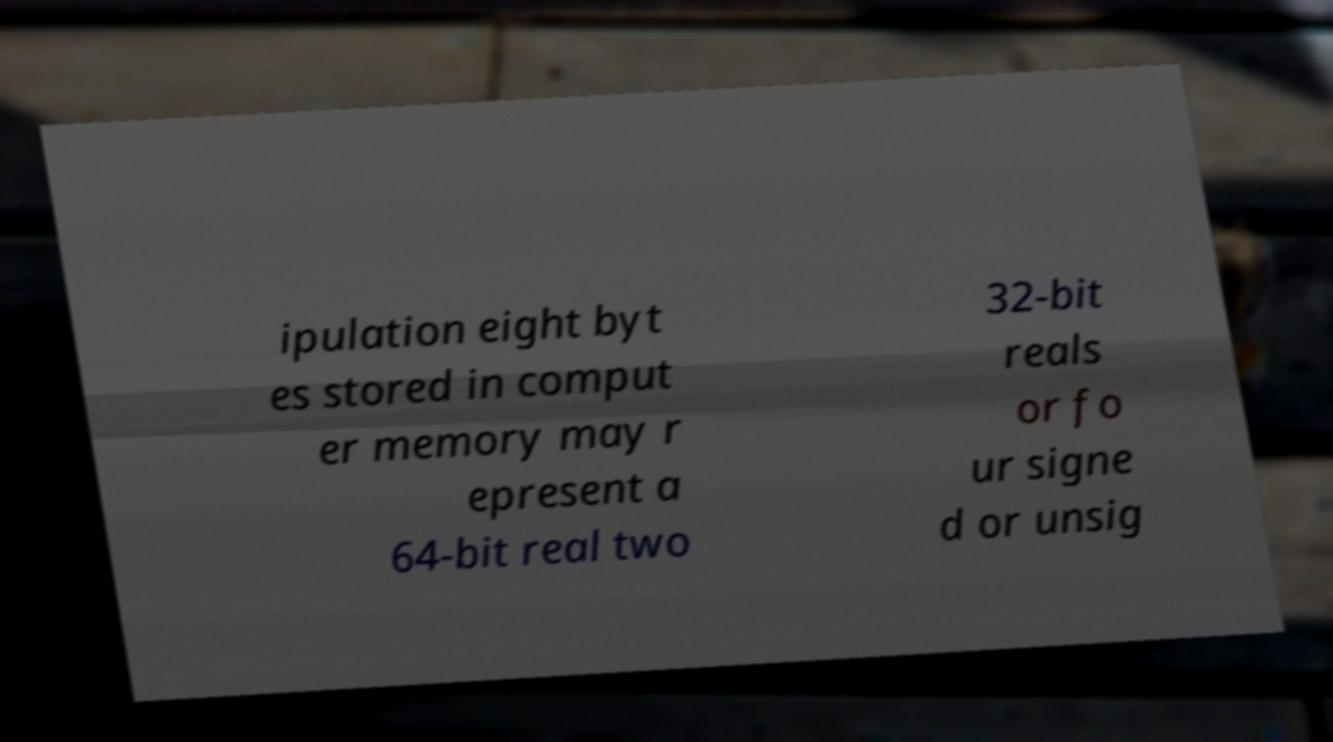There's text embedded in this image that I need extracted. Can you transcribe it verbatim? ipulation eight byt es stored in comput er memory may r epresent a 64-bit real two 32-bit reals or fo ur signe d or unsig 